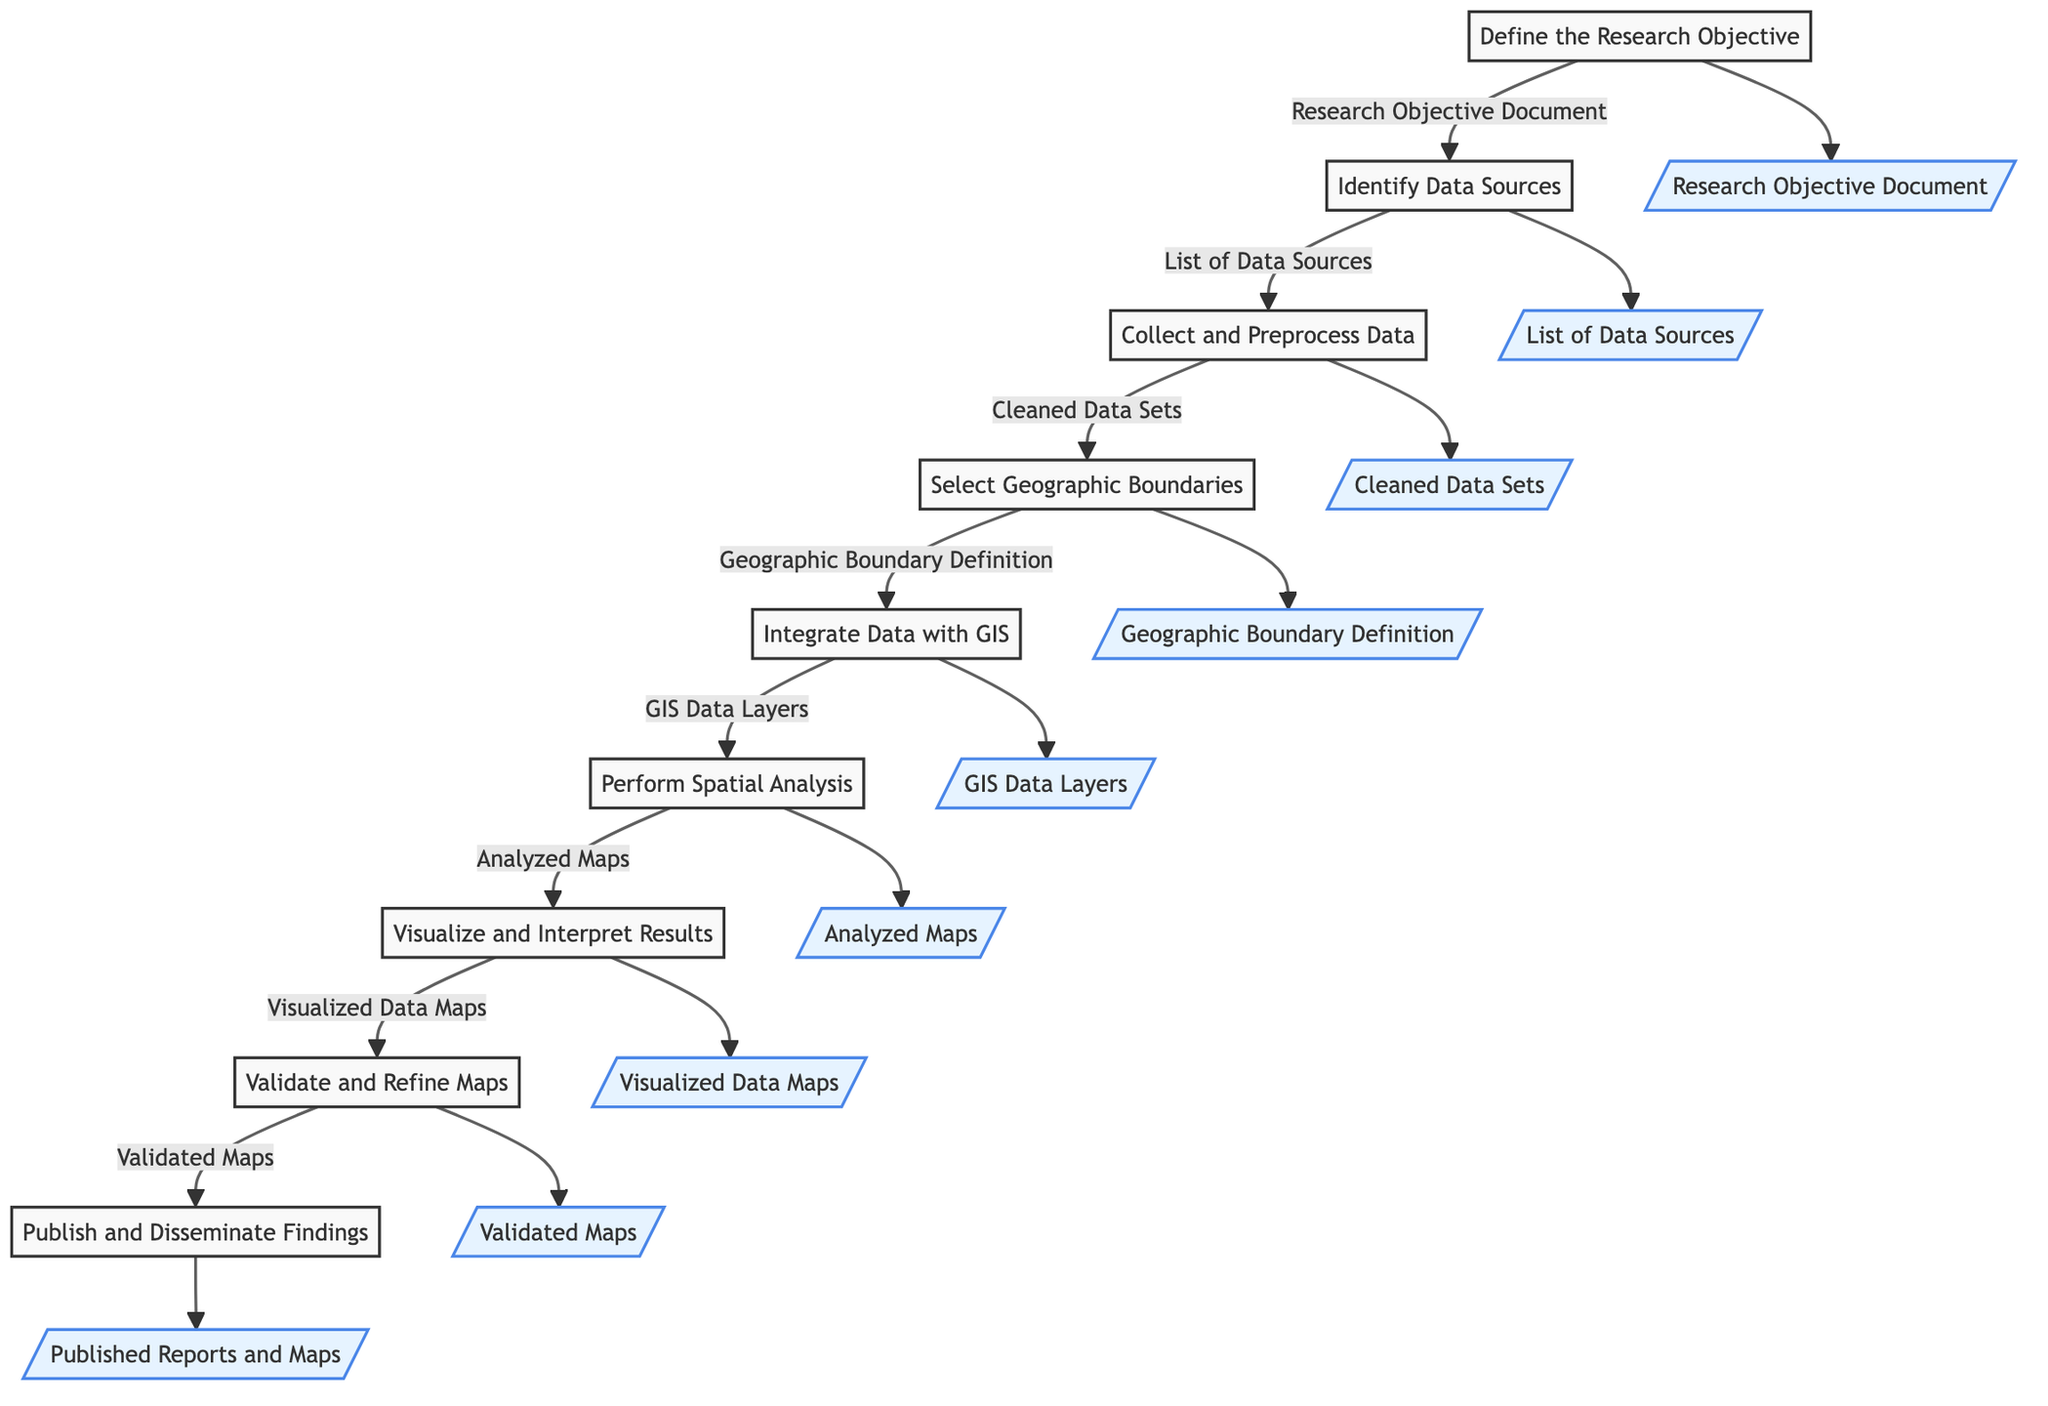What is the first step in the procedure? The diagram starts with "Define the Research Objective," indicating that this is the initial step in the process.
Answer: Define the Research Objective How many steps are there in total? By counting the nodes in the diagram, there are a total of nine steps listed sequentially.
Answer: Nine What follows after "Select Geographic Boundaries"? The next step after "Select Geographic Boundaries" is "Integrate Data with Geographic Information Systems (GIS)."
Answer: Integrate Data with GIS What document is produced after collecting and preprocessing data? According to the flow, the output after this step is "Cleaned Data Sets," which signifies the end result of that procedure.
Answer: Cleaned Data Sets Which step involves consulting with peers and stakeholders? The step that requires consultation is "Validate and Refine Maps," where accuracy and relevance are verified through discussions.
Answer: Validate and Refine Maps What is the output after performing spatial analysis? The output of the step "Perform Spatial Analysis" is "Analyzed Maps," which shows the result of this procedure.
Answer: Analyzed Maps How many outputs are listed in the diagram? There are nine distinct outputs specified in the diagram, one for each of the steps in the flowchart.
Answer: Nine What is the final output of this entire process? The last step, "Publish and Disseminate Findings," produces the final output, which is "Published Reports and Maps."
Answer: Published Reports and Maps Which step comes immediately before visualizing and interpreting results? The step that comes right before is "Perform Spatial Analysis," which sets up for the visualization process.
Answer: Perform Spatial Analysis 